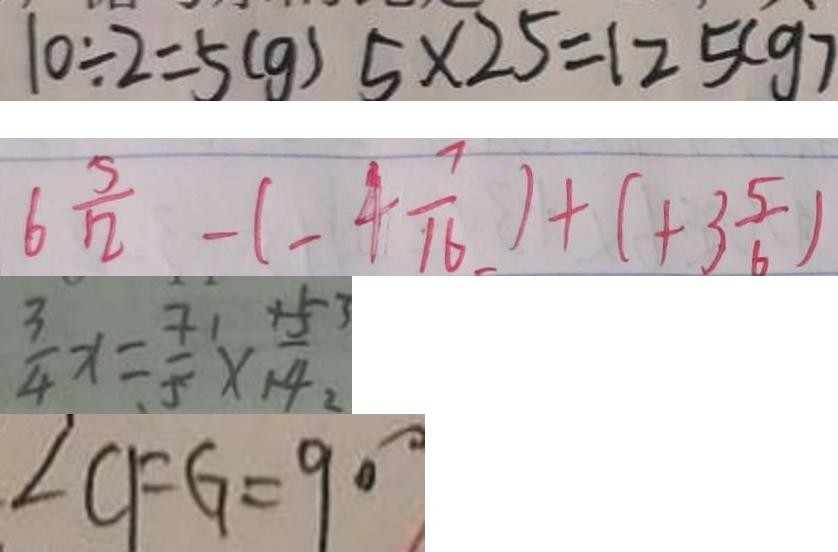<formula> <loc_0><loc_0><loc_500><loc_500>1 0 \div 2 = 5 ( g ) 5 \times 2 5 = 1 2 5 ( g ) 
 6 \frac { 5 } { 1 2 } - ( - 4 \frac { 7 } { 1 6 } ) + ( + 3 \frac { 5 } { 6 } ) 
 \frac { 3 } { 4 } x = \frac { 7 } { 5 } \times \frac { 4 5 3 } { 1 4 } 
 \angle C F G = 9 0 ^ { \circ }</formula> 